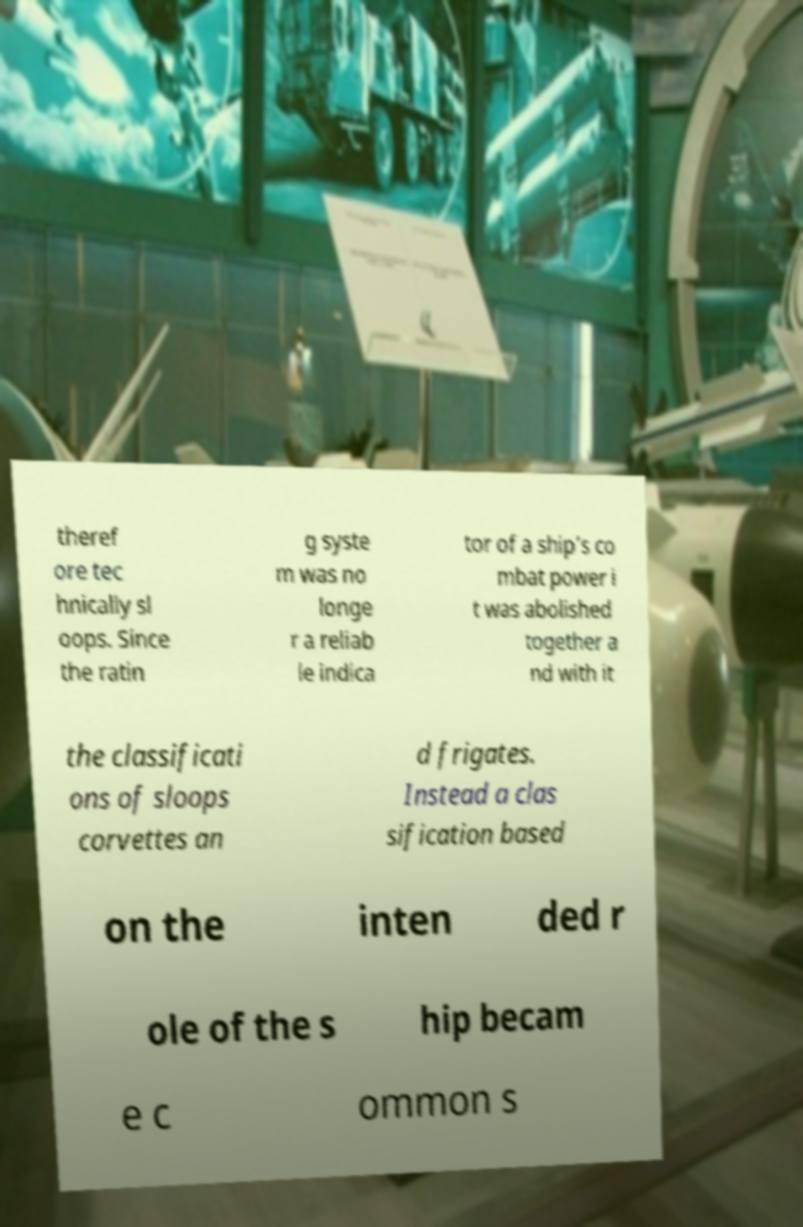Please identify and transcribe the text found in this image. theref ore tec hnically sl oops. Since the ratin g syste m was no longe r a reliab le indica tor of a ship's co mbat power i t was abolished together a nd with it the classificati ons of sloops corvettes an d frigates. Instead a clas sification based on the inten ded r ole of the s hip becam e c ommon s 